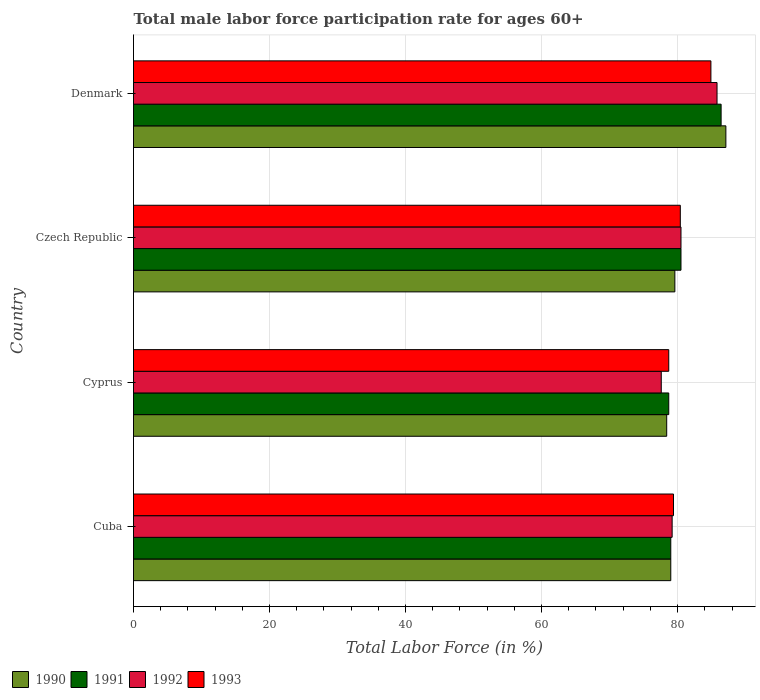How many different coloured bars are there?
Your answer should be very brief. 4. Are the number of bars per tick equal to the number of legend labels?
Give a very brief answer. Yes. Are the number of bars on each tick of the Y-axis equal?
Your response must be concise. Yes. What is the label of the 4th group of bars from the top?
Ensure brevity in your answer.  Cuba. In how many cases, is the number of bars for a given country not equal to the number of legend labels?
Your answer should be compact. 0. What is the male labor force participation rate in 1993 in Czech Republic?
Your answer should be compact. 80.4. Across all countries, what is the maximum male labor force participation rate in 1990?
Make the answer very short. 87.1. Across all countries, what is the minimum male labor force participation rate in 1992?
Make the answer very short. 77.6. In which country was the male labor force participation rate in 1991 maximum?
Your response must be concise. Denmark. In which country was the male labor force participation rate in 1992 minimum?
Ensure brevity in your answer.  Cyprus. What is the total male labor force participation rate in 1991 in the graph?
Make the answer very short. 324.6. What is the difference between the male labor force participation rate in 1992 in Czech Republic and that in Denmark?
Provide a short and direct response. -5.3. What is the difference between the male labor force participation rate in 1993 in Czech Republic and the male labor force participation rate in 1992 in Cuba?
Your answer should be very brief. 1.2. What is the average male labor force participation rate in 1992 per country?
Provide a short and direct response. 80.77. What is the difference between the male labor force participation rate in 1991 and male labor force participation rate in 1992 in Denmark?
Provide a succinct answer. 0.6. What is the ratio of the male labor force participation rate in 1990 in Cyprus to that in Czech Republic?
Give a very brief answer. 0.98. Is the male labor force participation rate in 1991 in Czech Republic less than that in Denmark?
Offer a very short reply. Yes. What is the difference between the highest and the second highest male labor force participation rate in 1990?
Provide a succinct answer. 7.5. What is the difference between the highest and the lowest male labor force participation rate in 1991?
Your answer should be very brief. 7.7. Is it the case that in every country, the sum of the male labor force participation rate in 1992 and male labor force participation rate in 1991 is greater than the male labor force participation rate in 1993?
Keep it short and to the point. Yes. How many bars are there?
Make the answer very short. 16. Are all the bars in the graph horizontal?
Provide a succinct answer. Yes. How many countries are there in the graph?
Provide a succinct answer. 4. What is the difference between two consecutive major ticks on the X-axis?
Provide a succinct answer. 20. How are the legend labels stacked?
Make the answer very short. Horizontal. What is the title of the graph?
Your response must be concise. Total male labor force participation rate for ages 60+. What is the label or title of the X-axis?
Provide a succinct answer. Total Labor Force (in %). What is the label or title of the Y-axis?
Ensure brevity in your answer.  Country. What is the Total Labor Force (in %) of 1990 in Cuba?
Make the answer very short. 79. What is the Total Labor Force (in %) in 1991 in Cuba?
Give a very brief answer. 79. What is the Total Labor Force (in %) in 1992 in Cuba?
Your answer should be compact. 79.2. What is the Total Labor Force (in %) in 1993 in Cuba?
Make the answer very short. 79.4. What is the Total Labor Force (in %) of 1990 in Cyprus?
Your response must be concise. 78.4. What is the Total Labor Force (in %) of 1991 in Cyprus?
Provide a succinct answer. 78.7. What is the Total Labor Force (in %) in 1992 in Cyprus?
Give a very brief answer. 77.6. What is the Total Labor Force (in %) of 1993 in Cyprus?
Offer a very short reply. 78.7. What is the Total Labor Force (in %) of 1990 in Czech Republic?
Your answer should be very brief. 79.6. What is the Total Labor Force (in %) of 1991 in Czech Republic?
Your response must be concise. 80.5. What is the Total Labor Force (in %) in 1992 in Czech Republic?
Offer a terse response. 80.5. What is the Total Labor Force (in %) in 1993 in Czech Republic?
Provide a succinct answer. 80.4. What is the Total Labor Force (in %) of 1990 in Denmark?
Keep it short and to the point. 87.1. What is the Total Labor Force (in %) in 1991 in Denmark?
Offer a very short reply. 86.4. What is the Total Labor Force (in %) in 1992 in Denmark?
Keep it short and to the point. 85.8. What is the Total Labor Force (in %) of 1993 in Denmark?
Keep it short and to the point. 84.9. Across all countries, what is the maximum Total Labor Force (in %) of 1990?
Offer a terse response. 87.1. Across all countries, what is the maximum Total Labor Force (in %) of 1991?
Offer a very short reply. 86.4. Across all countries, what is the maximum Total Labor Force (in %) in 1992?
Make the answer very short. 85.8. Across all countries, what is the maximum Total Labor Force (in %) in 1993?
Offer a terse response. 84.9. Across all countries, what is the minimum Total Labor Force (in %) of 1990?
Make the answer very short. 78.4. Across all countries, what is the minimum Total Labor Force (in %) of 1991?
Keep it short and to the point. 78.7. Across all countries, what is the minimum Total Labor Force (in %) in 1992?
Your response must be concise. 77.6. Across all countries, what is the minimum Total Labor Force (in %) of 1993?
Offer a terse response. 78.7. What is the total Total Labor Force (in %) in 1990 in the graph?
Ensure brevity in your answer.  324.1. What is the total Total Labor Force (in %) in 1991 in the graph?
Your answer should be very brief. 324.6. What is the total Total Labor Force (in %) of 1992 in the graph?
Keep it short and to the point. 323.1. What is the total Total Labor Force (in %) in 1993 in the graph?
Offer a very short reply. 323.4. What is the difference between the Total Labor Force (in %) in 1991 in Cuba and that in Cyprus?
Your answer should be very brief. 0.3. What is the difference between the Total Labor Force (in %) of 1991 in Cuba and that in Czech Republic?
Ensure brevity in your answer.  -1.5. What is the difference between the Total Labor Force (in %) in 1993 in Cuba and that in Czech Republic?
Provide a succinct answer. -1. What is the difference between the Total Labor Force (in %) of 1993 in Cuba and that in Denmark?
Offer a very short reply. -5.5. What is the difference between the Total Labor Force (in %) of 1990 in Cyprus and that in Czech Republic?
Your answer should be compact. -1.2. What is the difference between the Total Labor Force (in %) in 1991 in Cyprus and that in Czech Republic?
Give a very brief answer. -1.8. What is the difference between the Total Labor Force (in %) in 1992 in Cyprus and that in Czech Republic?
Your answer should be very brief. -2.9. What is the difference between the Total Labor Force (in %) of 1990 in Cyprus and that in Denmark?
Your answer should be compact. -8.7. What is the difference between the Total Labor Force (in %) of 1992 in Cyprus and that in Denmark?
Your answer should be compact. -8.2. What is the difference between the Total Labor Force (in %) of 1990 in Cuba and the Total Labor Force (in %) of 1993 in Cyprus?
Your response must be concise. 0.3. What is the difference between the Total Labor Force (in %) in 1991 in Cuba and the Total Labor Force (in %) in 1992 in Cyprus?
Offer a very short reply. 1.4. What is the difference between the Total Labor Force (in %) in 1992 in Cuba and the Total Labor Force (in %) in 1993 in Cyprus?
Offer a very short reply. 0.5. What is the difference between the Total Labor Force (in %) of 1990 in Cuba and the Total Labor Force (in %) of 1991 in Czech Republic?
Your answer should be compact. -1.5. What is the difference between the Total Labor Force (in %) in 1990 in Cuba and the Total Labor Force (in %) in 1993 in Czech Republic?
Provide a succinct answer. -1.4. What is the difference between the Total Labor Force (in %) in 1992 in Cuba and the Total Labor Force (in %) in 1993 in Czech Republic?
Give a very brief answer. -1.2. What is the difference between the Total Labor Force (in %) in 1990 in Cuba and the Total Labor Force (in %) in 1991 in Denmark?
Ensure brevity in your answer.  -7.4. What is the difference between the Total Labor Force (in %) in 1990 in Cyprus and the Total Labor Force (in %) in 1992 in Czech Republic?
Give a very brief answer. -2.1. What is the difference between the Total Labor Force (in %) in 1991 in Cyprus and the Total Labor Force (in %) in 1993 in Czech Republic?
Offer a very short reply. -1.7. What is the difference between the Total Labor Force (in %) of 1992 in Cyprus and the Total Labor Force (in %) of 1993 in Czech Republic?
Provide a succinct answer. -2.8. What is the difference between the Total Labor Force (in %) of 1990 in Cyprus and the Total Labor Force (in %) of 1993 in Denmark?
Your response must be concise. -6.5. What is the difference between the Total Labor Force (in %) of 1991 in Cyprus and the Total Labor Force (in %) of 1992 in Denmark?
Give a very brief answer. -7.1. What is the difference between the Total Labor Force (in %) in 1990 in Czech Republic and the Total Labor Force (in %) in 1992 in Denmark?
Make the answer very short. -6.2. What is the difference between the Total Labor Force (in %) in 1990 in Czech Republic and the Total Labor Force (in %) in 1993 in Denmark?
Keep it short and to the point. -5.3. What is the difference between the Total Labor Force (in %) in 1991 in Czech Republic and the Total Labor Force (in %) in 1992 in Denmark?
Ensure brevity in your answer.  -5.3. What is the difference between the Total Labor Force (in %) of 1991 in Czech Republic and the Total Labor Force (in %) of 1993 in Denmark?
Your response must be concise. -4.4. What is the difference between the Total Labor Force (in %) in 1992 in Czech Republic and the Total Labor Force (in %) in 1993 in Denmark?
Offer a very short reply. -4.4. What is the average Total Labor Force (in %) of 1990 per country?
Provide a short and direct response. 81.03. What is the average Total Labor Force (in %) in 1991 per country?
Keep it short and to the point. 81.15. What is the average Total Labor Force (in %) of 1992 per country?
Offer a terse response. 80.78. What is the average Total Labor Force (in %) of 1993 per country?
Keep it short and to the point. 80.85. What is the difference between the Total Labor Force (in %) of 1990 and Total Labor Force (in %) of 1991 in Cuba?
Your answer should be very brief. 0. What is the difference between the Total Labor Force (in %) of 1990 and Total Labor Force (in %) of 1993 in Cuba?
Your answer should be compact. -0.4. What is the difference between the Total Labor Force (in %) of 1991 and Total Labor Force (in %) of 1992 in Cuba?
Provide a succinct answer. -0.2. What is the difference between the Total Labor Force (in %) in 1991 and Total Labor Force (in %) in 1993 in Cuba?
Your answer should be very brief. -0.4. What is the difference between the Total Labor Force (in %) of 1990 and Total Labor Force (in %) of 1991 in Cyprus?
Your answer should be compact. -0.3. What is the difference between the Total Labor Force (in %) in 1990 and Total Labor Force (in %) in 1992 in Cyprus?
Keep it short and to the point. 0.8. What is the difference between the Total Labor Force (in %) in 1990 and Total Labor Force (in %) in 1993 in Cyprus?
Provide a short and direct response. -0.3. What is the difference between the Total Labor Force (in %) of 1991 and Total Labor Force (in %) of 1992 in Cyprus?
Your response must be concise. 1.1. What is the difference between the Total Labor Force (in %) in 1991 and Total Labor Force (in %) in 1993 in Cyprus?
Your response must be concise. 0. What is the difference between the Total Labor Force (in %) of 1992 and Total Labor Force (in %) of 1993 in Cyprus?
Provide a succinct answer. -1.1. What is the difference between the Total Labor Force (in %) of 1990 and Total Labor Force (in %) of 1992 in Czech Republic?
Your response must be concise. -0.9. What is the difference between the Total Labor Force (in %) in 1990 and Total Labor Force (in %) in 1993 in Czech Republic?
Your response must be concise. -0.8. What is the difference between the Total Labor Force (in %) of 1991 and Total Labor Force (in %) of 1992 in Czech Republic?
Make the answer very short. 0. What is the difference between the Total Labor Force (in %) in 1991 and Total Labor Force (in %) in 1993 in Czech Republic?
Provide a succinct answer. 0.1. What is the difference between the Total Labor Force (in %) of 1992 and Total Labor Force (in %) of 1993 in Czech Republic?
Keep it short and to the point. 0.1. What is the difference between the Total Labor Force (in %) in 1990 and Total Labor Force (in %) in 1991 in Denmark?
Provide a short and direct response. 0.7. What is the difference between the Total Labor Force (in %) in 1990 and Total Labor Force (in %) in 1993 in Denmark?
Your response must be concise. 2.2. What is the difference between the Total Labor Force (in %) of 1991 and Total Labor Force (in %) of 1992 in Denmark?
Your answer should be very brief. 0.6. What is the difference between the Total Labor Force (in %) of 1991 and Total Labor Force (in %) of 1993 in Denmark?
Offer a very short reply. 1.5. What is the ratio of the Total Labor Force (in %) in 1990 in Cuba to that in Cyprus?
Provide a succinct answer. 1.01. What is the ratio of the Total Labor Force (in %) in 1991 in Cuba to that in Cyprus?
Provide a short and direct response. 1. What is the ratio of the Total Labor Force (in %) in 1992 in Cuba to that in Cyprus?
Make the answer very short. 1.02. What is the ratio of the Total Labor Force (in %) in 1993 in Cuba to that in Cyprus?
Make the answer very short. 1.01. What is the ratio of the Total Labor Force (in %) of 1990 in Cuba to that in Czech Republic?
Offer a very short reply. 0.99. What is the ratio of the Total Labor Force (in %) in 1991 in Cuba to that in Czech Republic?
Offer a terse response. 0.98. What is the ratio of the Total Labor Force (in %) of 1992 in Cuba to that in Czech Republic?
Your answer should be compact. 0.98. What is the ratio of the Total Labor Force (in %) of 1993 in Cuba to that in Czech Republic?
Ensure brevity in your answer.  0.99. What is the ratio of the Total Labor Force (in %) in 1990 in Cuba to that in Denmark?
Make the answer very short. 0.91. What is the ratio of the Total Labor Force (in %) in 1991 in Cuba to that in Denmark?
Your response must be concise. 0.91. What is the ratio of the Total Labor Force (in %) in 1992 in Cuba to that in Denmark?
Your response must be concise. 0.92. What is the ratio of the Total Labor Force (in %) in 1993 in Cuba to that in Denmark?
Offer a terse response. 0.94. What is the ratio of the Total Labor Force (in %) in 1990 in Cyprus to that in Czech Republic?
Offer a very short reply. 0.98. What is the ratio of the Total Labor Force (in %) in 1991 in Cyprus to that in Czech Republic?
Make the answer very short. 0.98. What is the ratio of the Total Labor Force (in %) in 1992 in Cyprus to that in Czech Republic?
Offer a very short reply. 0.96. What is the ratio of the Total Labor Force (in %) of 1993 in Cyprus to that in Czech Republic?
Give a very brief answer. 0.98. What is the ratio of the Total Labor Force (in %) in 1990 in Cyprus to that in Denmark?
Your response must be concise. 0.9. What is the ratio of the Total Labor Force (in %) in 1991 in Cyprus to that in Denmark?
Ensure brevity in your answer.  0.91. What is the ratio of the Total Labor Force (in %) of 1992 in Cyprus to that in Denmark?
Your response must be concise. 0.9. What is the ratio of the Total Labor Force (in %) of 1993 in Cyprus to that in Denmark?
Your response must be concise. 0.93. What is the ratio of the Total Labor Force (in %) in 1990 in Czech Republic to that in Denmark?
Your answer should be compact. 0.91. What is the ratio of the Total Labor Force (in %) in 1991 in Czech Republic to that in Denmark?
Give a very brief answer. 0.93. What is the ratio of the Total Labor Force (in %) of 1992 in Czech Republic to that in Denmark?
Make the answer very short. 0.94. What is the ratio of the Total Labor Force (in %) in 1993 in Czech Republic to that in Denmark?
Your answer should be very brief. 0.95. What is the difference between the highest and the second highest Total Labor Force (in %) of 1991?
Offer a very short reply. 5.9. What is the difference between the highest and the second highest Total Labor Force (in %) in 1993?
Offer a terse response. 4.5. What is the difference between the highest and the lowest Total Labor Force (in %) of 1990?
Keep it short and to the point. 8.7. What is the difference between the highest and the lowest Total Labor Force (in %) in 1992?
Keep it short and to the point. 8.2. 